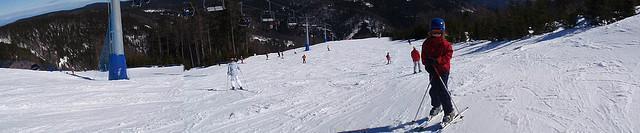What is a term used for this place?
From the following four choices, select the correct answer to address the question.
Options: First base, grapes, hoop, downhill. Downhill. 